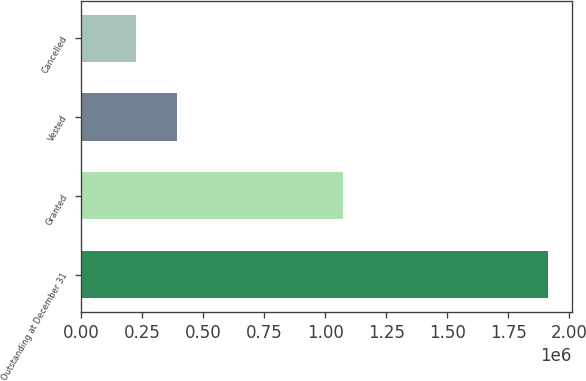Convert chart. <chart><loc_0><loc_0><loc_500><loc_500><bar_chart><fcel>Outstanding at December 31<fcel>Granted<fcel>Vested<fcel>Cancelled<nl><fcel>1.91353e+06<fcel>1.0738e+06<fcel>395196<fcel>226493<nl></chart> 